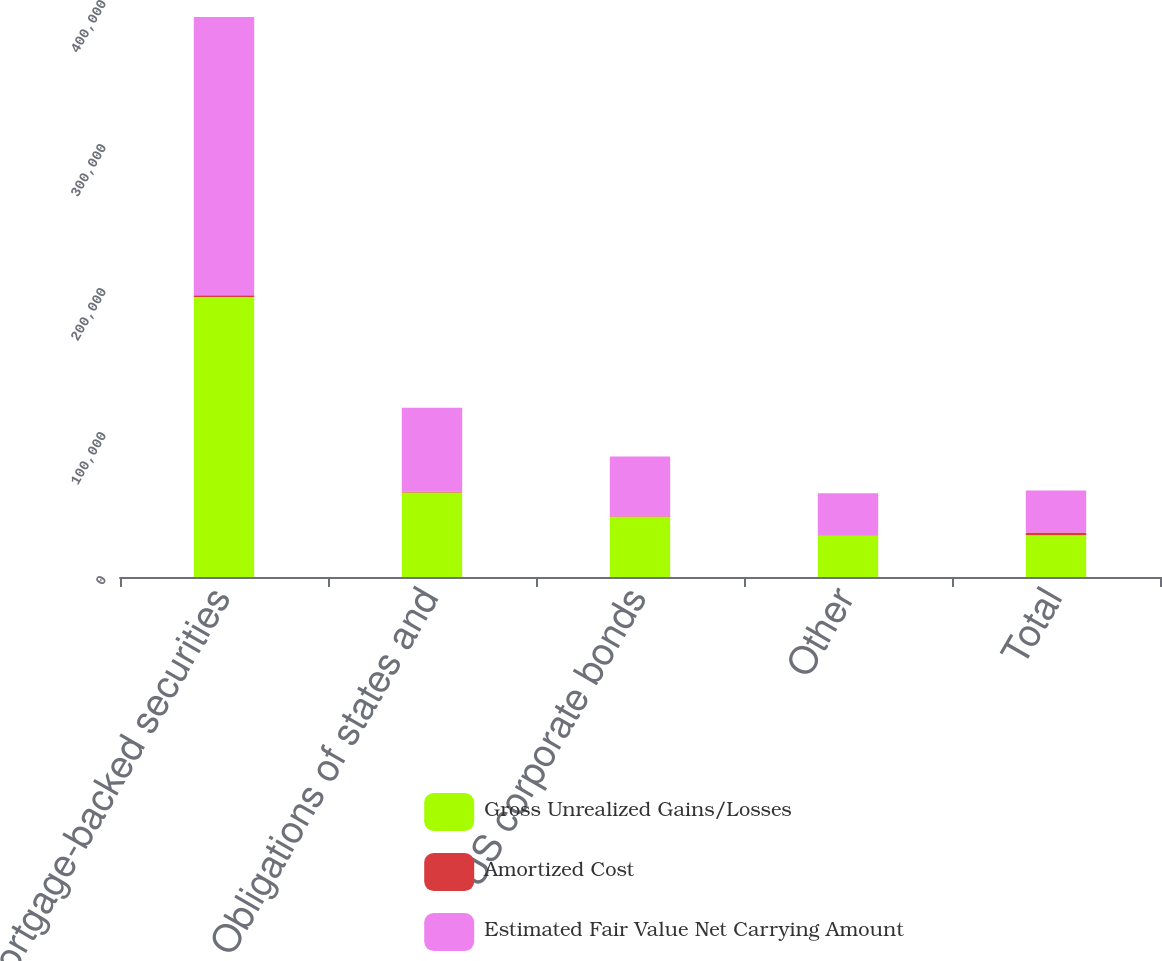Convert chart to OTSL. <chart><loc_0><loc_0><loc_500><loc_500><stacked_bar_chart><ecel><fcel>Mortgage-backed securities<fcel>Obligations of states and<fcel>US corporate bonds<fcel>Other<fcel>Total<nl><fcel>Gross Unrealized Gains/Losses<fcel>194422<fcel>58764<fcel>41861<fcel>29077<fcel>29077<nl><fcel>Amortized Cost<fcel>1237<fcel>409<fcel>260<fcel>3<fcel>1909<nl><fcel>Estimated Fair Value Net Carrying Amount<fcel>193185<fcel>58355<fcel>41601<fcel>29074<fcel>29077<nl></chart> 